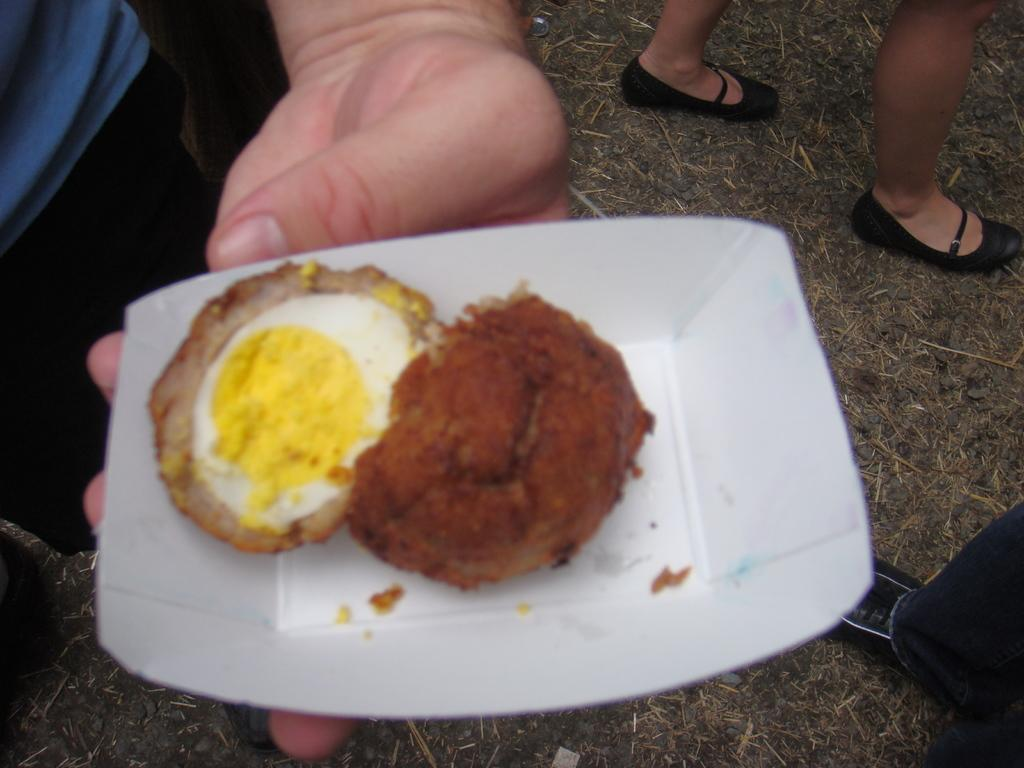What is the main object in the image? There is an egg in a paper bowl in the image. Can you describe any other objects or features in the image? Yes, there are legs of two persons visible in the image. What type of skin can be seen on the kettle in the image? There is no kettle present in the image, so it is not possible to determine what type of skin might be on it. 